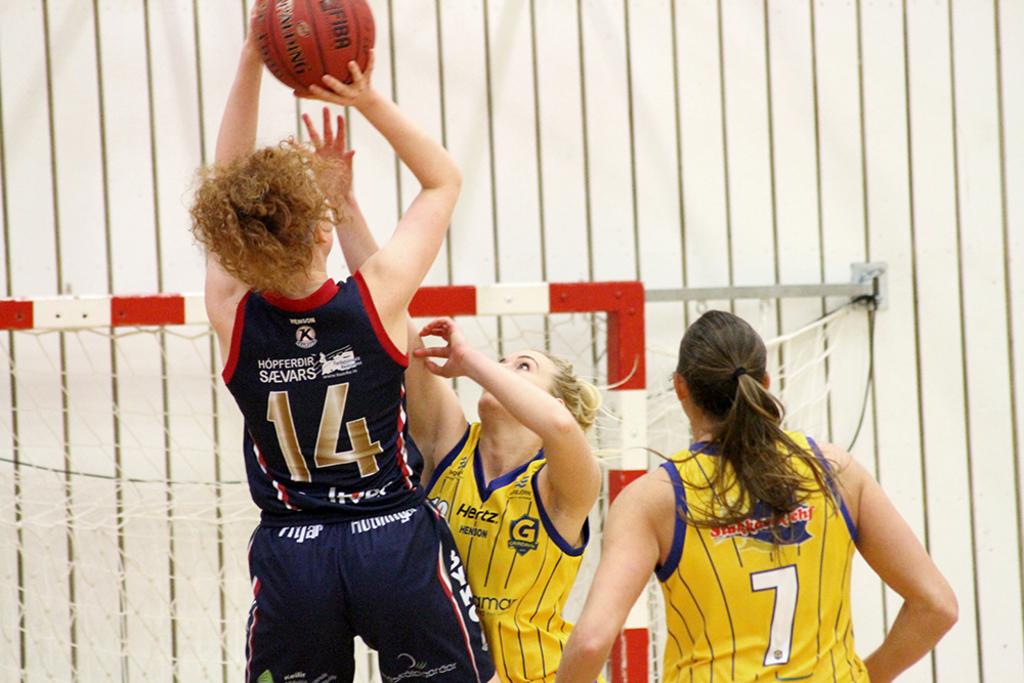What number is taking the shot?
Make the answer very short. 14. What is the number of the yellow jersey?
Your response must be concise. 7. 